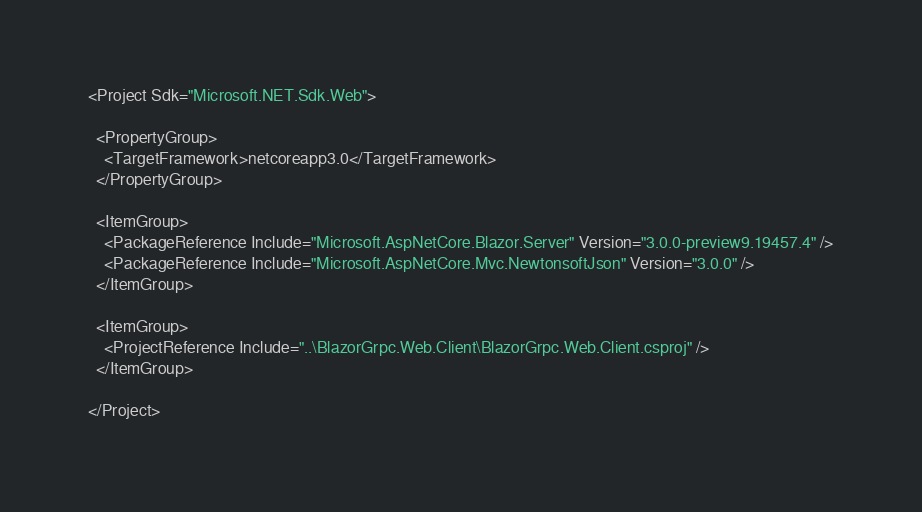<code> <loc_0><loc_0><loc_500><loc_500><_XML_><Project Sdk="Microsoft.NET.Sdk.Web">

  <PropertyGroup>
    <TargetFramework>netcoreapp3.0</TargetFramework>
  </PropertyGroup>

  <ItemGroup>
    <PackageReference Include="Microsoft.AspNetCore.Blazor.Server" Version="3.0.0-preview9.19457.4" />
    <PackageReference Include="Microsoft.AspNetCore.Mvc.NewtonsoftJson" Version="3.0.0" />
  </ItemGroup>

  <ItemGroup>
    <ProjectReference Include="..\BlazorGrpc.Web.Client\BlazorGrpc.Web.Client.csproj" />
  </ItemGroup>

</Project>
</code> 